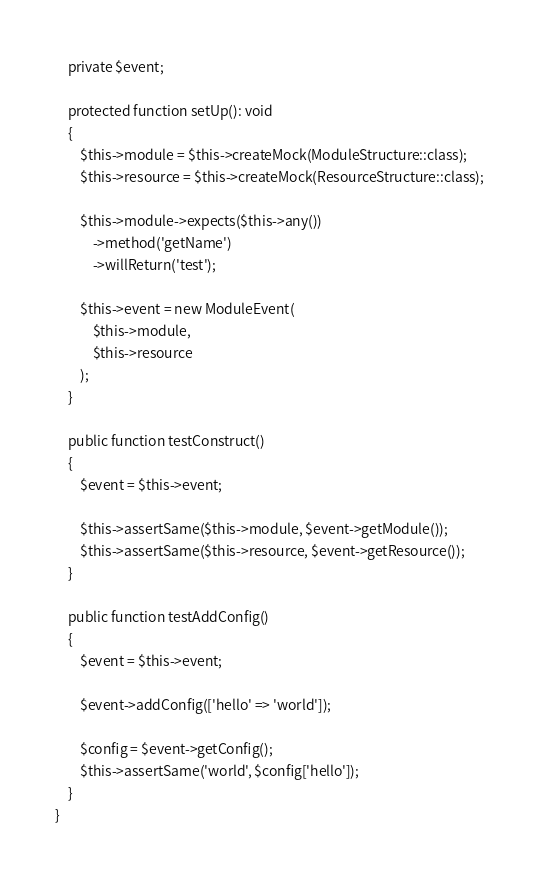<code> <loc_0><loc_0><loc_500><loc_500><_PHP_>    private $event;

    protected function setUp(): void
    {
        $this->module = $this->createMock(ModuleStructure::class);
        $this->resource = $this->createMock(ResourceStructure::class);

        $this->module->expects($this->any())
            ->method('getName')
            ->willReturn('test');

        $this->event = new ModuleEvent(
            $this->module,
            $this->resource
        );
    }

    public function testConstruct()
    {
        $event = $this->event;

        $this->assertSame($this->module, $event->getModule());
        $this->assertSame($this->resource, $event->getResource());
    }

    public function testAddConfig()
    {
        $event = $this->event;

        $event->addConfig(['hello' => 'world']);

        $config = $event->getConfig();
        $this->assertSame('world', $config['hello']);
    }
}
</code> 